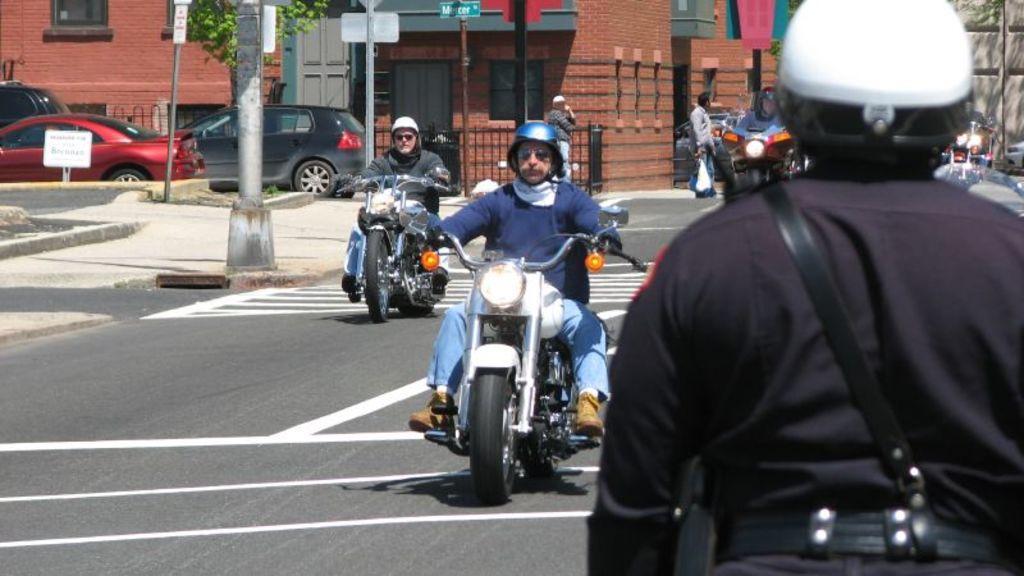Please provide a concise description of this image. There are three people wearing helmet and riding motorbike. Here is a person standing. These are the cars. This looks like a pole. This is a building with windows. This is a tree. I can see two people standing here. Here is a board. This looks like a wall. 